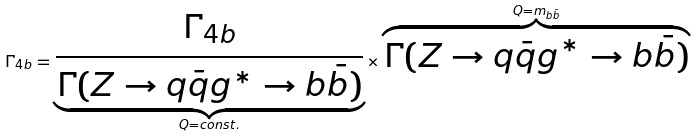<formula> <loc_0><loc_0><loc_500><loc_500>\Gamma _ { 4 b } = \underbrace { \frac { \Gamma _ { 4 b } } { \Gamma ( Z \rightarrow q \bar { q } g ^ { * } \rightarrow b \bar { b } ) } } _ { Q = c o n s t . } \times \overbrace { \Gamma ( Z \rightarrow q \bar { q } g ^ { * } \rightarrow b \bar { b } ) } ^ { Q = m _ { b \bar { b } } }</formula> 